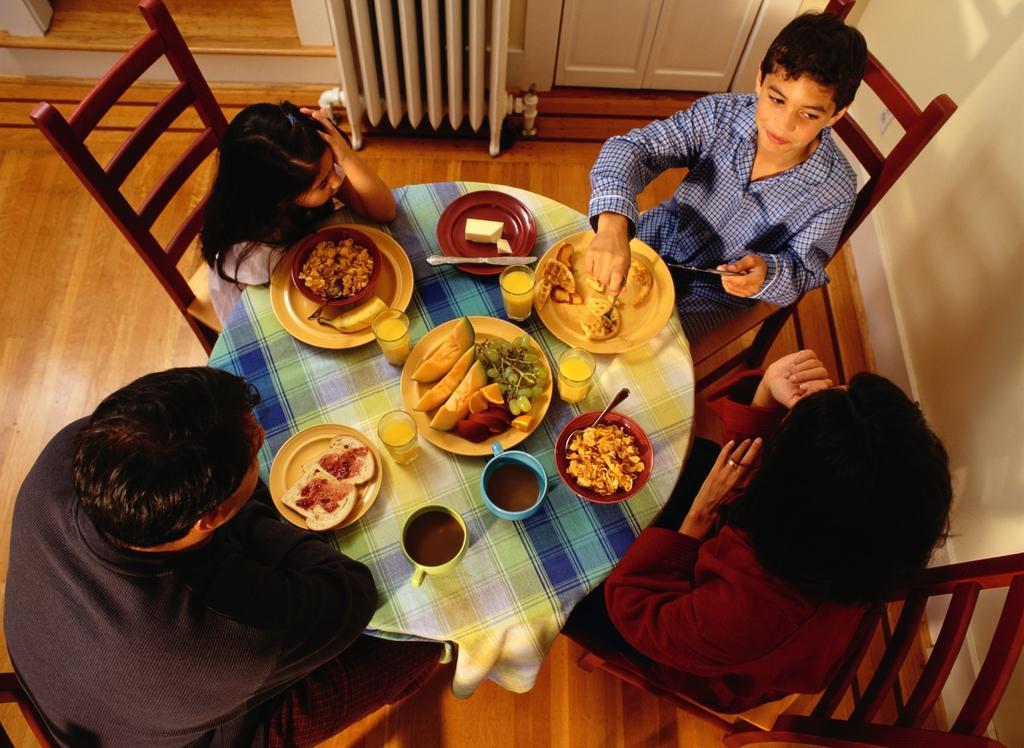Please provide a concise description of this image. This Picture describe about the top view of the the room in which a group of two children, woman and a man sitting on the dining table and having the breakfast. In middle we can see table on which corn flake, bread with jam, fruits in the plate etc.. A boy wearing blue shirt is sitting and eating the food from the plate and a girl wearing girl dress is eating corn flakes in bowl. Behind We can see white door and white wall around them with wooden flooring in down. 